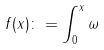<formula> <loc_0><loc_0><loc_500><loc_500>f ( x ) \colon = \int _ { 0 } ^ { x } \omega</formula> 